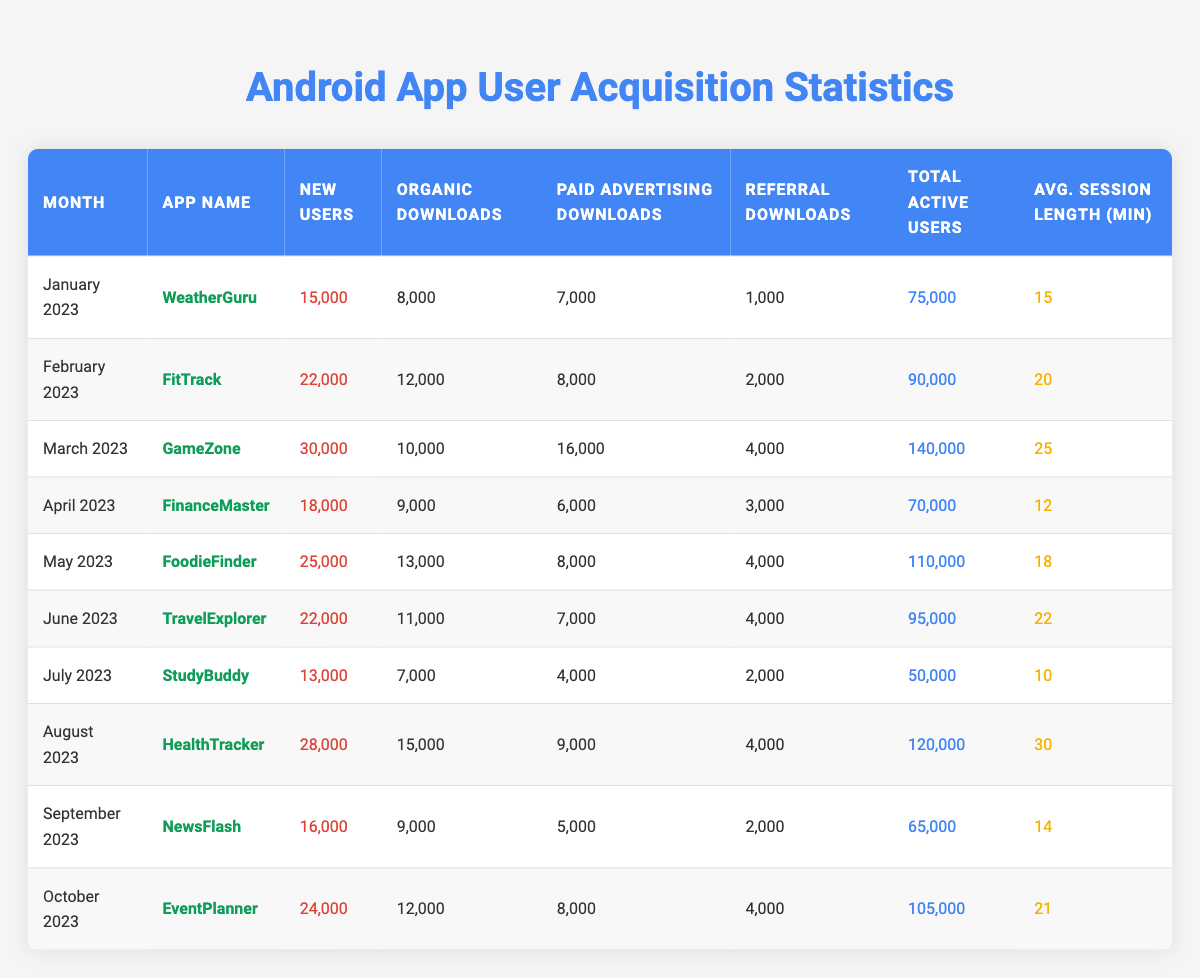What is the app with the highest number of new users in March 2023? In March 2023, the app "GameZone" had 30,000 new users, which is the highest for that month.
Answer: GameZone Which month had the lowest total active users? In July 2023, the total active users were 50,000, which is the lowest compared to other months in the data.
Answer: July 2023 What percentage of new users came from paid advertising for the app HealthTracker? HealthTracker had 28,000 new users, with 9,000 from paid advertising. The percentage calculation is (9,000 / 28,000) * 100 = 32.14%.
Answer: 32.14% How many new users did EventPlanner gain compared to the number of organic downloads? EventPlanner gained 24,000 new users and had 12,000 organic downloads, resulting in a difference of 24,000 - 12,000 = 12,000 new users more than organic downloads.
Answer: 12,000 Which app had the longest average session length in August 2023? In August 2023, HealthTracker had an average session length of 30 minutes, which is the longest duration for that month.
Answer: HealthTracker What is the total number of organic downloads for all apps from January to October 2023? Summing the organic downloads from each month: 8,000 + 12,000 + 10,000 + 9,000 + 13,000 + 11,000 + 7,000 + 15,000 + 9,000 + 12,000 equals a total of 96,000 organic downloads.
Answer: 96,000 Was there a month where the number of new users was lower than the number of referral downloads for any app? In July 2023, StudyBuddy had 13,000 new users while having only 2,000 referral downloads, indicating that new users were higher than referral downloads. So, there was no month with lower new users than referral downloads.
Answer: No What is the average number of new users across all apps for the months listed? To find the average, sum the new users (15,000 + 22,000 + 30,000 + 18,000 + 25,000 + 22,000 + 13,000 + 28,000 + 16,000 + 24,000) =  248,000 and divide by the count of months (10): 248,000 / 10 = 24,800 new users on average.
Answer: 24,800 How many apps had new users over 20,000 in June and July combined? For June, TravelExplorer had 22,000 new users and for July, StudyBuddy had 13,000 new users. Thus in June and July combined, only TravelExplorer exceeds 20,000 new users.
Answer: 1 app What is the total new user growth from January 2023 to October 2023? New users in January 2023 were 15,000, and in October 2023 were 24,000. Thus, the growth calculation is 24,000 - 15,000 = 9,000 more new users in October compared to January.
Answer: 9,000 